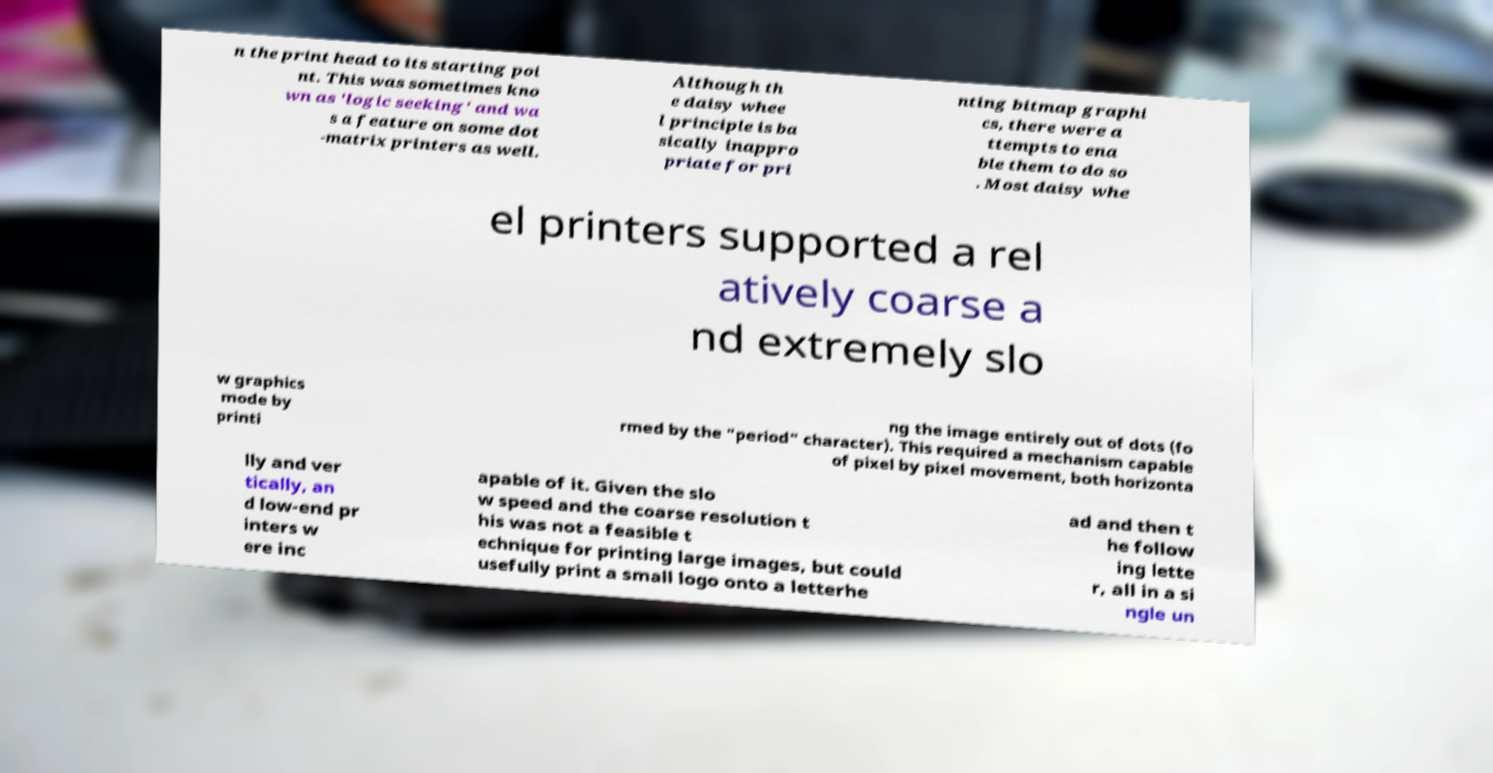Please read and relay the text visible in this image. What does it say? n the print head to its starting poi nt. This was sometimes kno wn as 'logic seeking' and wa s a feature on some dot -matrix printers as well. Although th e daisy whee l principle is ba sically inappro priate for pri nting bitmap graphi cs, there were a ttempts to ena ble them to do so . Most daisy whe el printers supported a rel atively coarse a nd extremely slo w graphics mode by printi ng the image entirely out of dots (fo rmed by the "period" character). This required a mechanism capable of pixel by pixel movement, both horizonta lly and ver tically, an d low-end pr inters w ere inc apable of it. Given the slo w speed and the coarse resolution t his was not a feasible t echnique for printing large images, but could usefully print a small logo onto a letterhe ad and then t he follow ing lette r, all in a si ngle un 